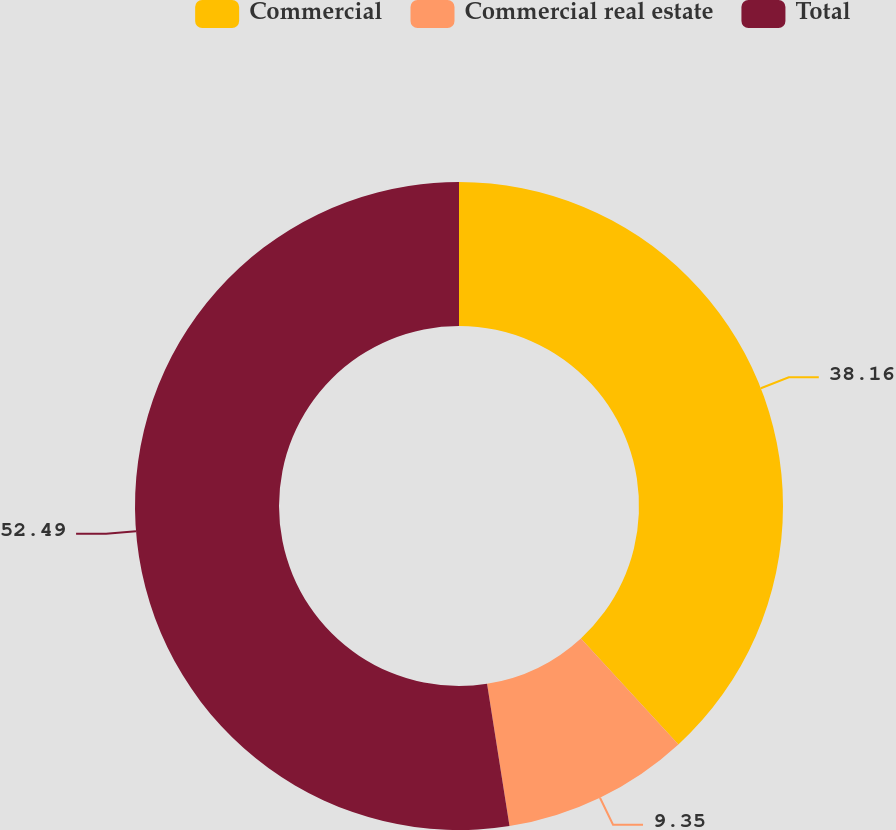<chart> <loc_0><loc_0><loc_500><loc_500><pie_chart><fcel>Commercial<fcel>Commercial real estate<fcel>Total<nl><fcel>38.16%<fcel>9.35%<fcel>52.49%<nl></chart> 